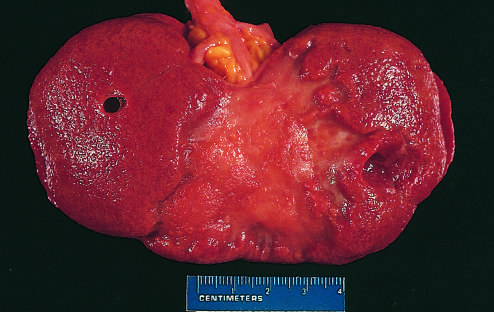what is replaced by a large fibrotic scar?
Answer the question using a single word or phrase. Remote kidney infarct 